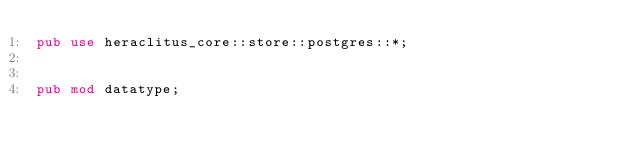Convert code to text. <code><loc_0><loc_0><loc_500><loc_500><_Rust_>pub use heraclitus_core::store::postgres::*;


pub mod datatype;
</code> 